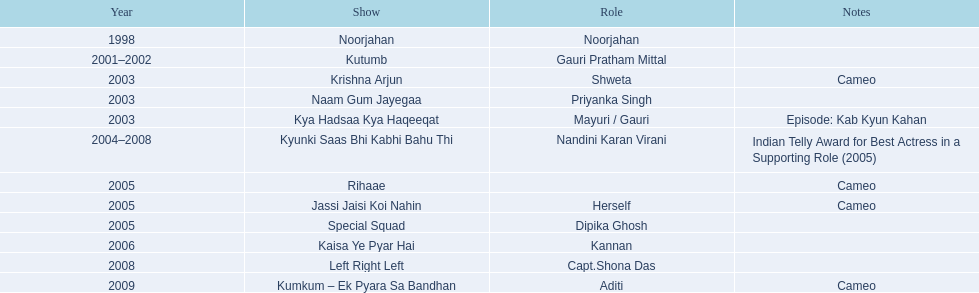How many programs are there? Noorjahan, Kutumb, Krishna Arjun, Naam Gum Jayegaa, Kya Hadsaa Kya Haqeeqat, Kyunki Saas Bhi Kabhi Bahu Thi, Rihaae, Jassi Jaisi Koi Nahin, Special Squad, Kaisa Ye Pyar Hai, Left Right Left, Kumkum – Ek Pyara Sa Bandhan. How many programs did she make a guest appearance in? Krishna Arjun, Rihaae, Jassi Jaisi Koi Nahin, Kumkum – Ek Pyara Sa Bandhan. Of those, how many did she portray herself? Jassi Jaisi Koi Nahin. 